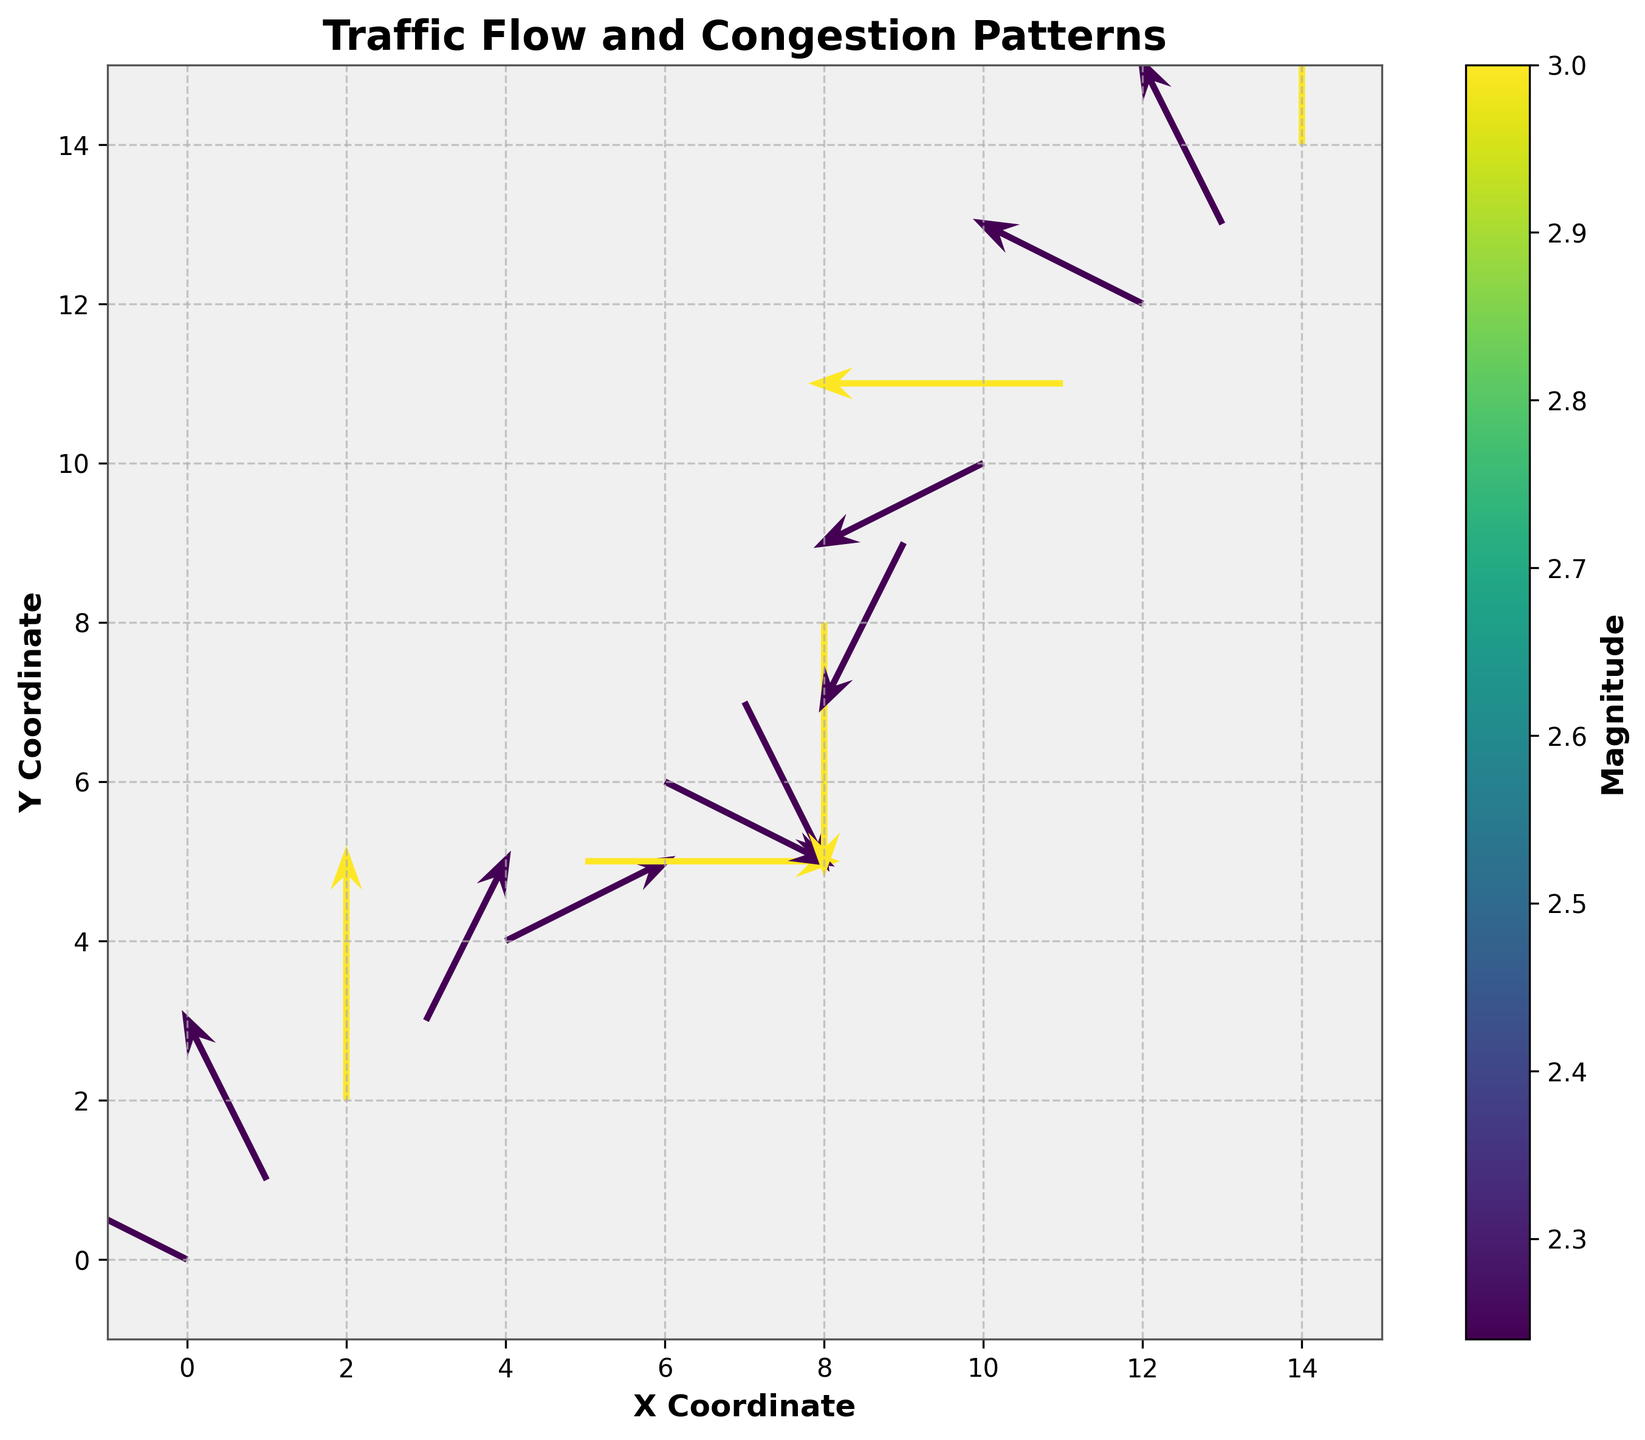What's the title of the figure? The title of the figure is located at the top-center of the plot.
Answer: Traffic Flow and Congestion Patterns What are the x and y-axis labels? The x-axis label is located along the horizontal axis, and the y-axis label is found along the vertical axis.
Answer: X Coordinate, Y Coordinate How many data points are represented in the plot? By counting the number of arrows in the plot, we determine the number of data points.
Answer: 15 What is the maximum value of the Magnitude shown on the color bar? The color bar reflects the range of magnitudes; the maximum value is at the upper end of the scale.
Answer: 3.00 Which arrows indicate the highest congestion, and what is their direction? Arrows with the highest magnitude values are in color corresponding to 3.00 on the color bar, indicating these are the longest arrows. We can check which arrows have these values.
Answer: (2,2) upward, (5,5) rightward, (8,8) downward, (11,11) leftward, (14,14) upward What's the average of all magnitudes? Sum up all magnitudes and divide by the number of data points: 2.24 + 2.24 + 3.00 + 2.24 + 2.24 + 3.00 + 2.24 + 2.24 + 3.00 + 2.24 + 2.24 + 3.00 + 2.24 + 2.24 + 3.00. Total sum = 39.84. Average = 39.84 / 15.
Answer: 2.66 Which arrow points more upward, the one at (0,0) or (1,1)? Compare the v components of the arrows at (0,0) and (1,1). The v component for (0,0) is 1, and for (1,1) it is 2.
Answer: (1,1) Which direction is the arrow at (7,7) pointing, and what is its magnitude? From the given data, the arrow at (7,7) has coordinates u = 1 and v = -2, which means it points downwards to the right. Its magnitude is 2.24.
Answer: Downwards to the right, 2.24 Which arrow at an odd-indexed (x,y) position has the lowest magnitude? Odd-indexed positions are (1,1), (3,3), (5,5), (7,7), (9,9), (11,11), and (13,13). Comparing the magnitudes, which are 2.24, 2.24, 3.00, 2.24, 2.24, 3.00, and 2.24 respectively, the lowest magnitude is 2.24.
Answer: (1,1), (3,3), (7,7), (9,9), (13,13) What is the general trend of traffic flow from x = 0 to x = 14? By observing the direction and trend of arrows from x=0 to x=14, it can be noted that the trend starts with more negative u components and moves progressively to more positive u components as x increases.
Answer: Negative to positive 